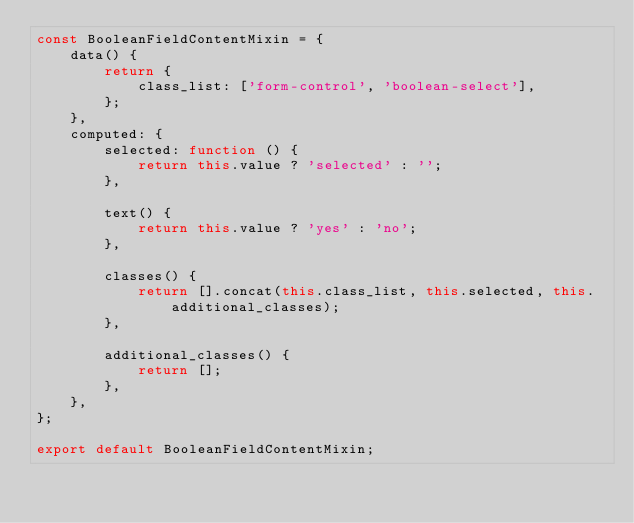Convert code to text. <code><loc_0><loc_0><loc_500><loc_500><_JavaScript_>const BooleanFieldContentMixin = {
    data() {
        return {
            class_list: ['form-control', 'boolean-select'],
        };
    },
    computed: {
        selected: function () {
            return this.value ? 'selected' : '';
        },

        text() {
            return this.value ? 'yes' : 'no';
        },

        classes() {
            return [].concat(this.class_list, this.selected, this.additional_classes);
        },

        additional_classes() {
            return [];
        },
    },
};

export default BooleanFieldContentMixin;
</code> 